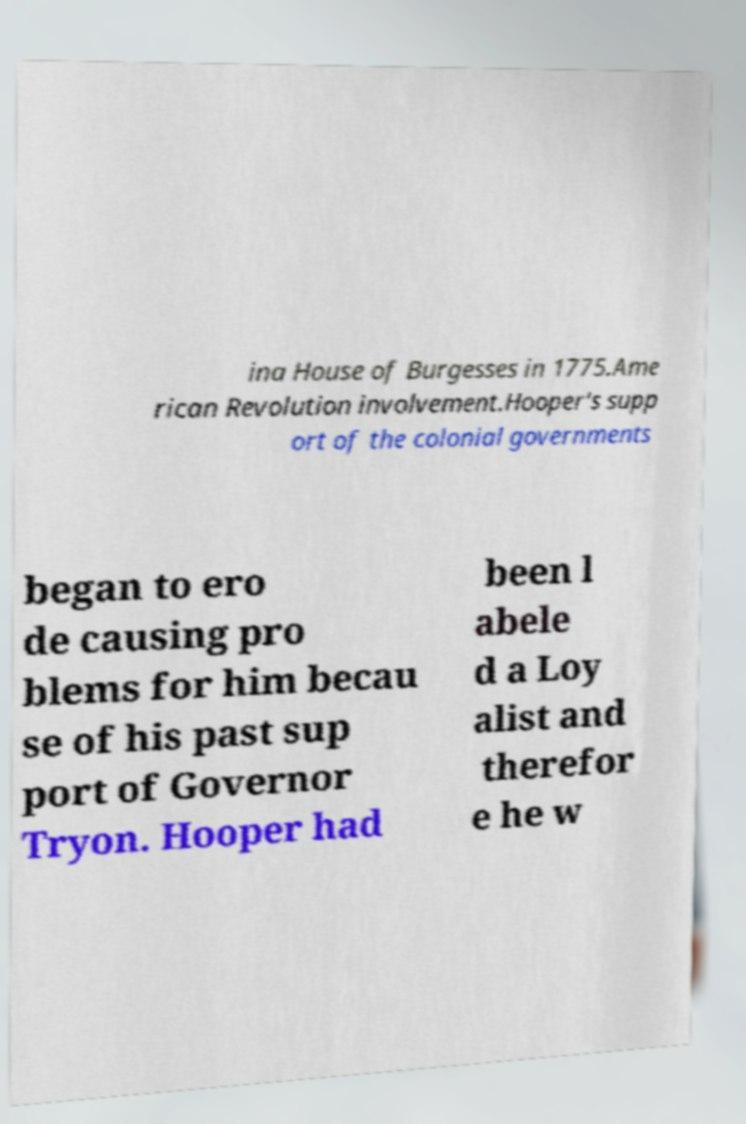For documentation purposes, I need the text within this image transcribed. Could you provide that? ina House of Burgesses in 1775.Ame rican Revolution involvement.Hooper's supp ort of the colonial governments began to ero de causing pro blems for him becau se of his past sup port of Governor Tryon. Hooper had been l abele d a Loy alist and therefor e he w 